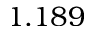Convert formula to latex. <formula><loc_0><loc_0><loc_500><loc_500>1 . 1 8 9</formula> 